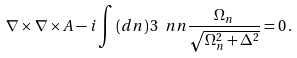<formula> <loc_0><loc_0><loc_500><loc_500>\nabla \times \nabla \times A - i \int \, ( d n ) \, 3 \ n n \frac { \Omega _ { n } } { \sqrt { \Omega _ { n } ^ { 2 } + \Delta ^ { 2 } } } = 0 \, .</formula> 